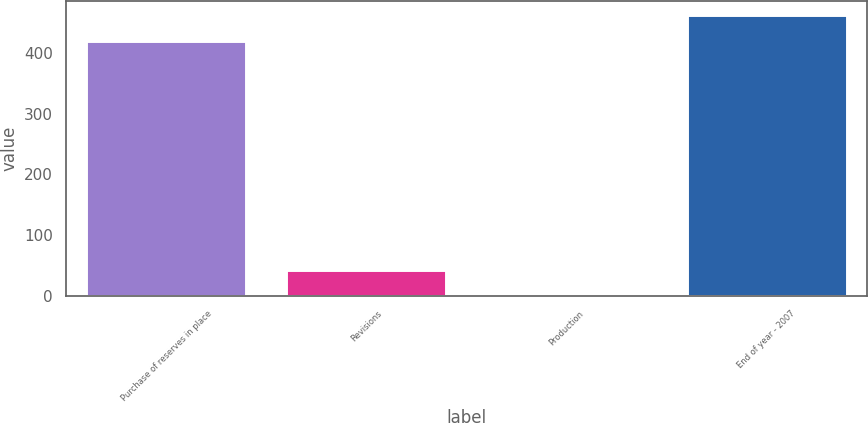Convert chart. <chart><loc_0><loc_0><loc_500><loc_500><bar_chart><fcel>Purchase of reserves in place<fcel>Revisions<fcel>Production<fcel>End of year - 2007<nl><fcel>420<fcel>43<fcel>1<fcel>462<nl></chart> 